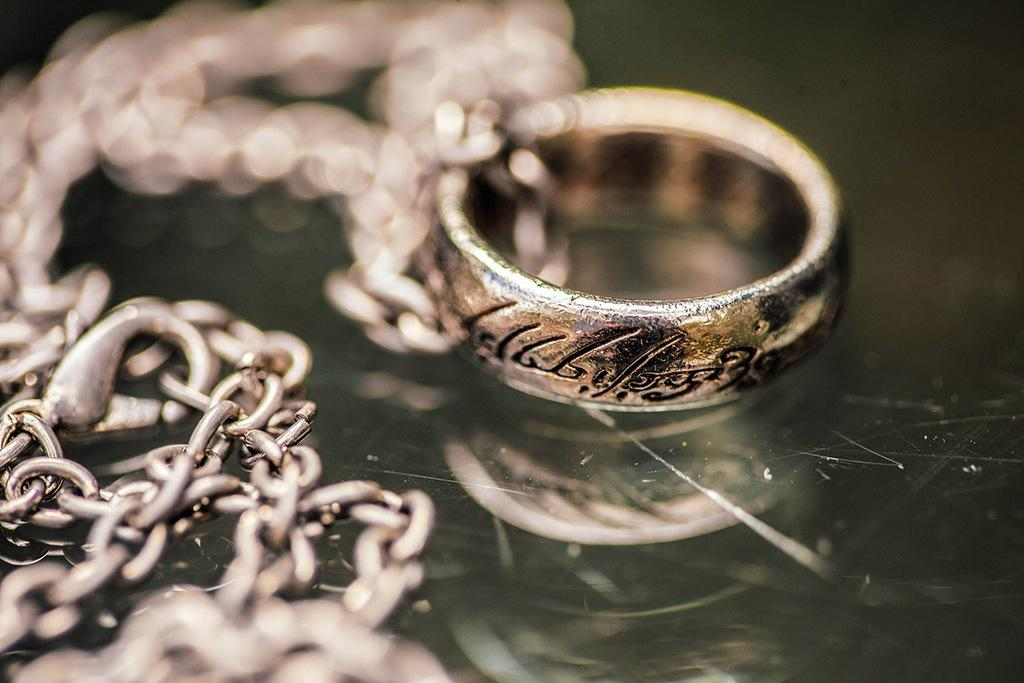What is the main object in the image? There is a locket on a chain in the image. Where is the locket and chain placed? The locket and chain are placed on a glass surface. What type of honey is being suggested for use with the oranges in the image? There is no honey or oranges present in the image; it only features a locket on a chain placed on a glass surface. 